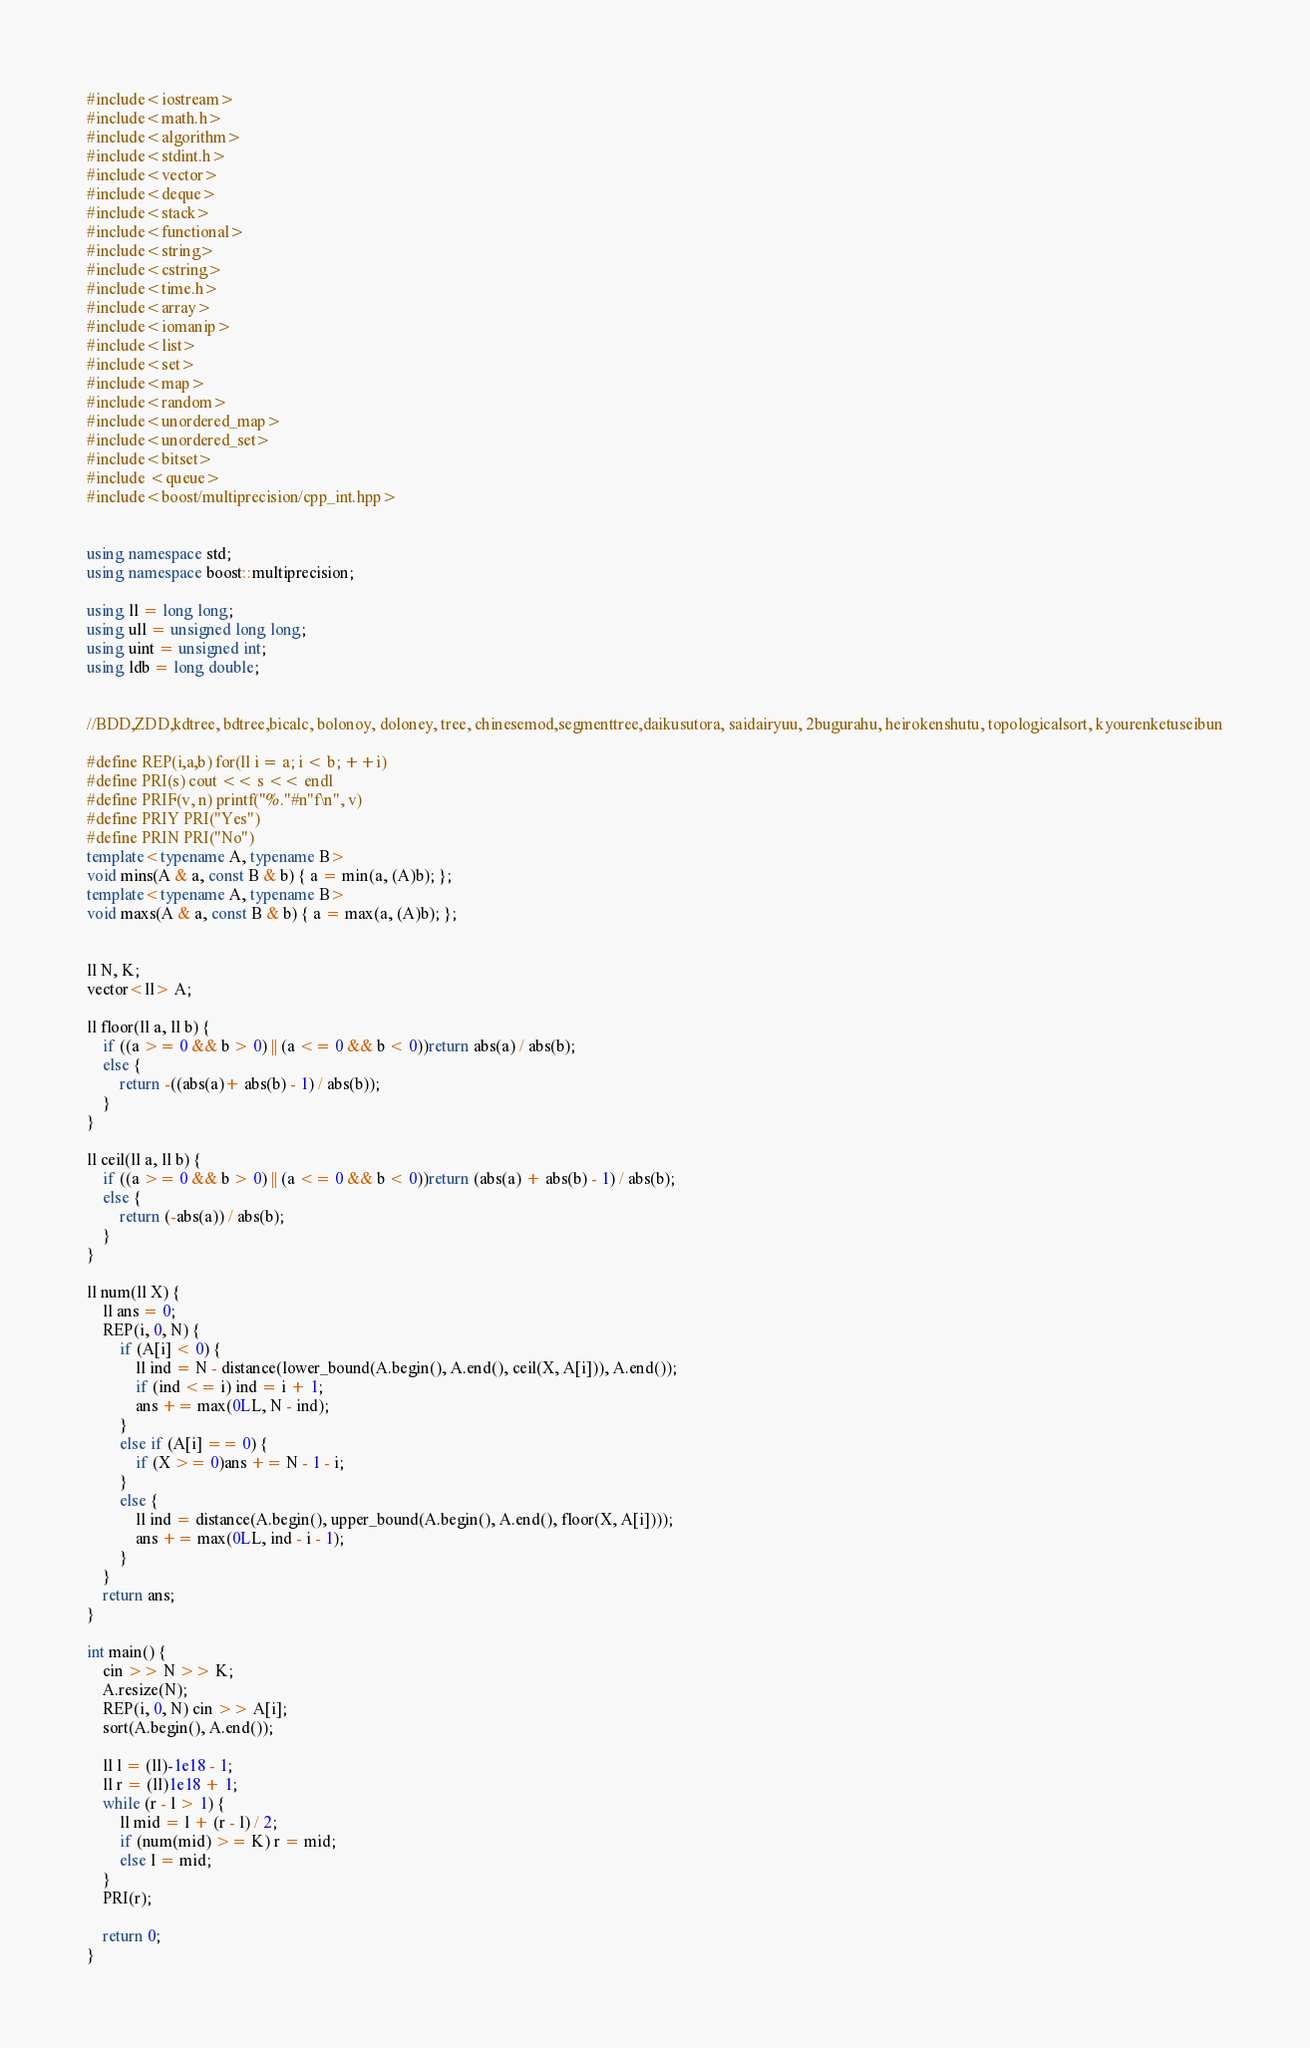Convert code to text. <code><loc_0><loc_0><loc_500><loc_500><_C++_>
#include<iostream>
#include<math.h>
#include<algorithm>
#include<stdint.h>
#include<vector>
#include<deque>
#include<stack>
#include<functional>
#include<string>
#include<cstring>
#include<time.h>
#include<array>
#include<iomanip>
#include<list>
#include<set>
#include<map>
#include<random>
#include<unordered_map>
#include<unordered_set>
#include<bitset>
#include <queue>
#include<boost/multiprecision/cpp_int.hpp>


using namespace std;
using namespace boost::multiprecision;

using ll = long long;
using ull = unsigned long long;
using uint = unsigned int;
using ldb = long double;


//BDD,ZDD,kdtree, bdtree,bicalc, bolonoy, doloney, tree, chinesemod,segmenttree,daikusutora, saidairyuu, 2bugurahu, heirokenshutu, topologicalsort, kyourenketuseibun

#define REP(i,a,b) for(ll i = a; i < b; ++i)
#define PRI(s) cout << s << endl
#define PRIF(v, n) printf("%."#n"f\n", v)
#define PRIY PRI("Yes")
#define PRIN PRI("No")
template<typename A, typename B>
void mins(A & a, const B & b) { a = min(a, (A)b); };
template<typename A, typename B>
void maxs(A & a, const B & b) { a = max(a, (A)b); };


ll N, K;
vector<ll> A;

ll floor(ll a, ll b) {
	if ((a >= 0 && b > 0) || (a <= 0 && b < 0))return abs(a) / abs(b);
	else {
		return -((abs(a)+ abs(b) - 1) / abs(b));
	}
}

ll ceil(ll a, ll b) {
	if ((a >= 0 && b > 0) || (a <= 0 && b < 0))return (abs(a) + abs(b) - 1) / abs(b);
	else {
		return (-abs(a)) / abs(b);
	}
}

ll num(ll X) {
	ll ans = 0;
	REP(i, 0, N) {
		if (A[i] < 0) {
			ll ind = N - distance(lower_bound(A.begin(), A.end(), ceil(X, A[i])), A.end());
			if (ind <= i) ind = i + 1;
			ans += max(0LL, N - ind);
		}
		else if (A[i] == 0) {
			if (X >= 0)ans += N - 1 - i;
		}
		else {
			ll ind = distance(A.begin(), upper_bound(A.begin(), A.end(), floor(X, A[i])));
			ans += max(0LL, ind - i - 1);
		}
	}
	return ans;
}

int main() {
	cin >> N >> K;
	A.resize(N);
	REP(i, 0, N) cin >> A[i];
	sort(A.begin(), A.end());

	ll l = (ll)-1e18 - 1;
	ll r = (ll)1e18 + 1;
	while (r - l > 1) {
		ll mid = l + (r - l) / 2;
		if (num(mid) >= K) r = mid;
		else l = mid;
	}
	PRI(r);

	return 0;
}</code> 